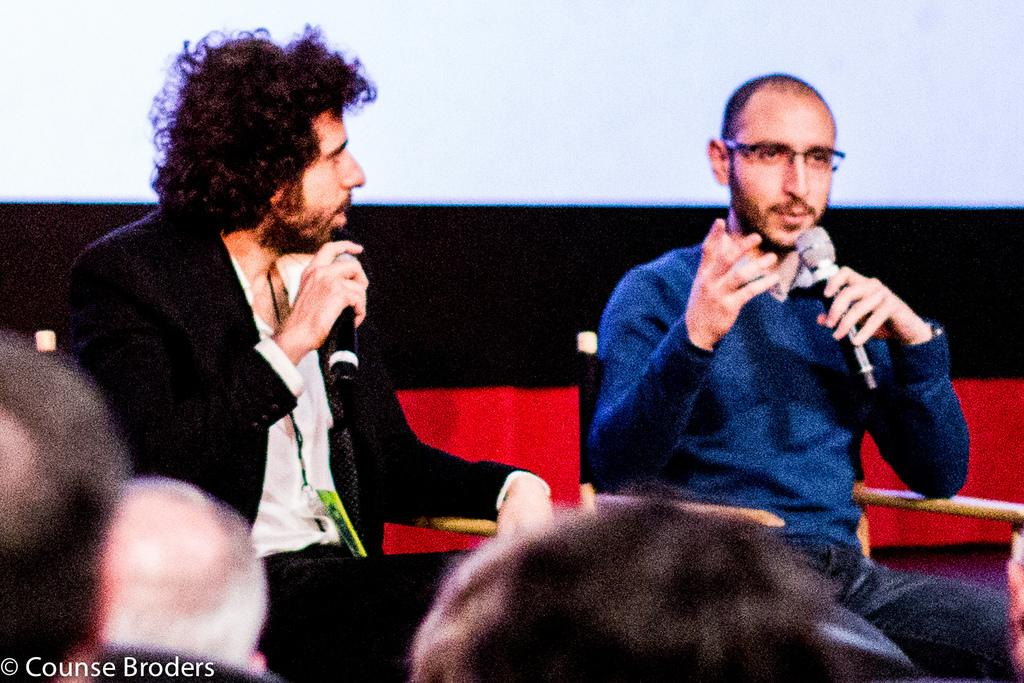How many people are in the image? There are two persons in the image. What are the two persons doing in the image? The two persons are sitting on chairs and talking. What are the two persons holding in their hands? The two persons are holding mics in their hands. Can you describe the people in front of the two persons? There are people in front of the two persons, but their specific actions or characteristics are not mentioned in the facts. What is visible in the background of the image? There is a wall in the background of the image. What type of flag is being waved by the person in the image? There is no flag present in the image. Can you describe the picture hanging on the wall in the background? There is no mention of a picture hanging on the wall in the background; only a wall is mentioned. How much salt is on the table in the image? There is no salt present in the image. 